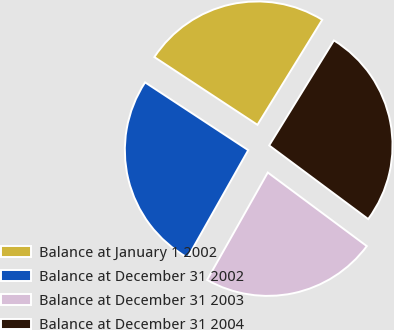<chart> <loc_0><loc_0><loc_500><loc_500><pie_chart><fcel>Balance at January 1 2002<fcel>Balance at December 31 2002<fcel>Balance at December 31 2003<fcel>Balance at December 31 2004<nl><fcel>24.54%<fcel>26.07%<fcel>23.01%<fcel>26.38%<nl></chart> 